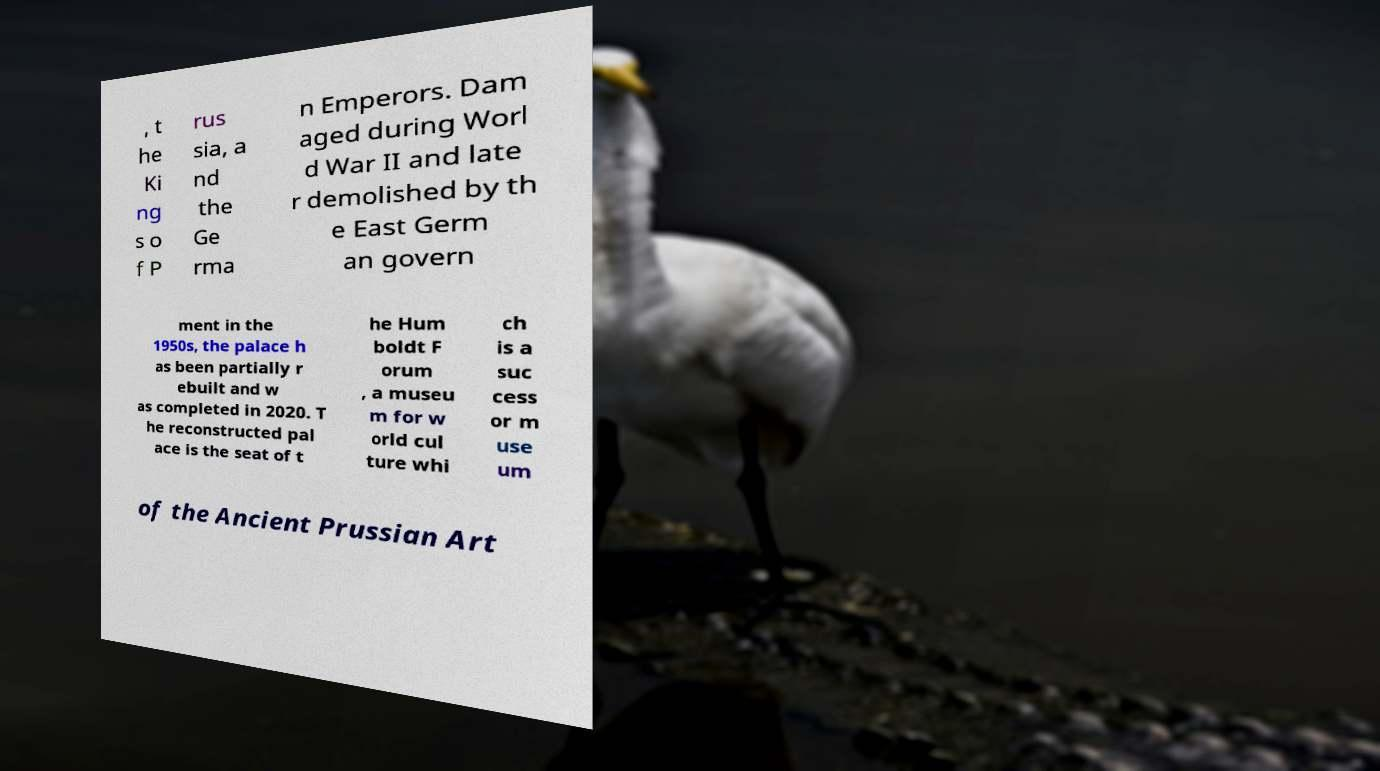Could you assist in decoding the text presented in this image and type it out clearly? , t he Ki ng s o f P rus sia, a nd the Ge rma n Emperors. Dam aged during Worl d War II and late r demolished by th e East Germ an govern ment in the 1950s, the palace h as been partially r ebuilt and w as completed in 2020. T he reconstructed pal ace is the seat of t he Hum boldt F orum , a museu m for w orld cul ture whi ch is a suc cess or m use um of the Ancient Prussian Art 